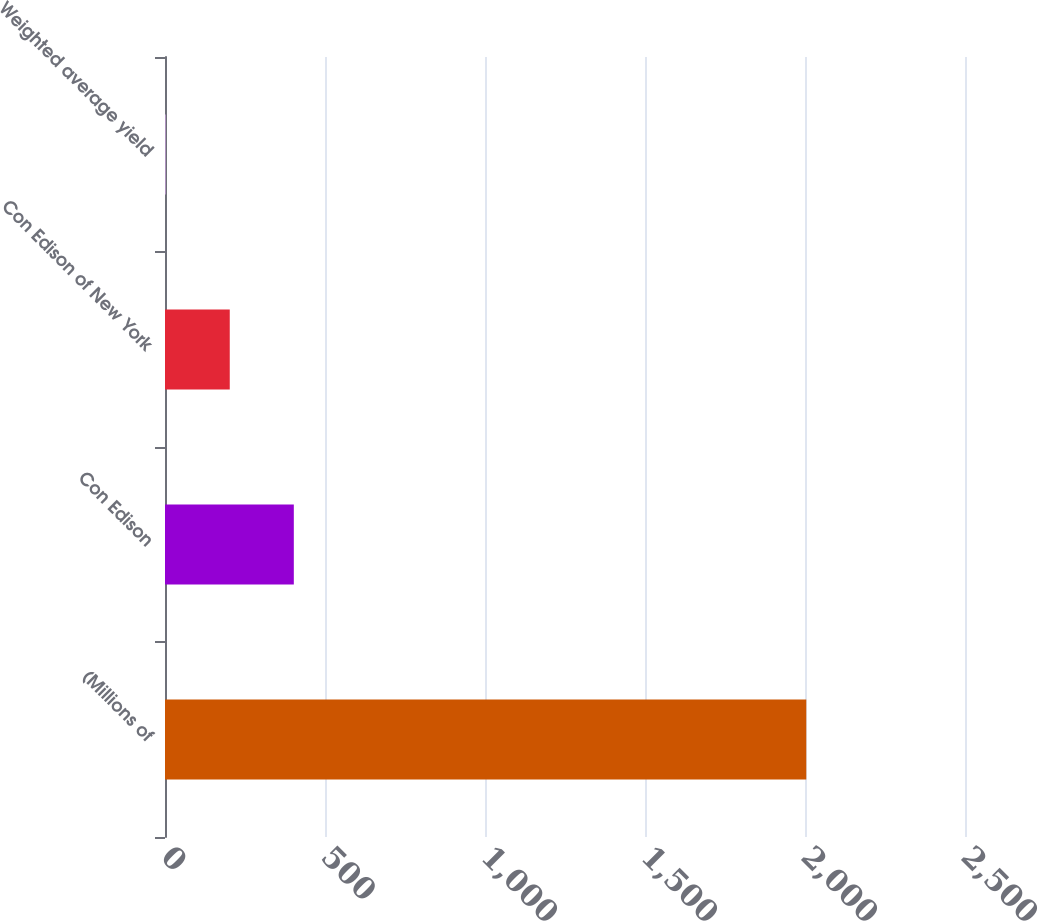<chart> <loc_0><loc_0><loc_500><loc_500><bar_chart><fcel>(Millions of<fcel>Con Edison<fcel>Con Edison of New York<fcel>Weighted average yield<nl><fcel>2004<fcel>402.56<fcel>202.38<fcel>2.2<nl></chart> 